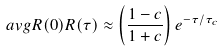Convert formula to latex. <formula><loc_0><loc_0><loc_500><loc_500>\ a v g { R ( 0 ) R ( \tau ) } \approx \left ( \frac { 1 - c } { 1 + c } \right ) e ^ { - \tau / \tau _ { c } }</formula> 